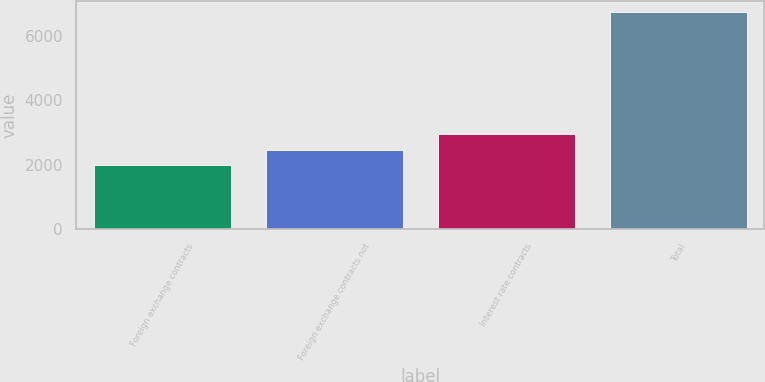Convert chart. <chart><loc_0><loc_0><loc_500><loc_500><bar_chart><fcel>Foreign exchange contracts<fcel>Foreign exchange contracts not<fcel>Interest rate contracts<fcel>Total<nl><fcel>1990<fcel>2464.9<fcel>2939.8<fcel>6739<nl></chart> 